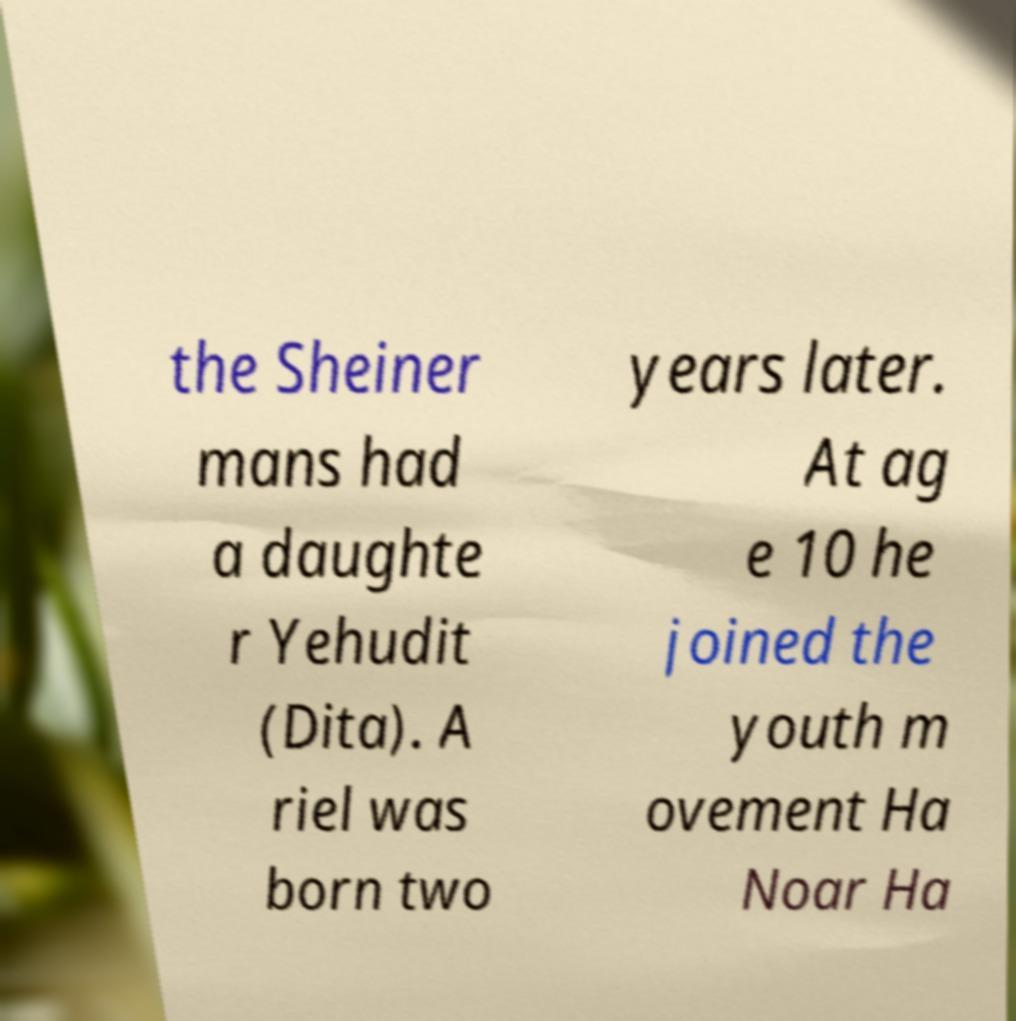For documentation purposes, I need the text within this image transcribed. Could you provide that? the Sheiner mans had a daughte r Yehudit (Dita). A riel was born two years later. At ag e 10 he joined the youth m ovement Ha Noar Ha 